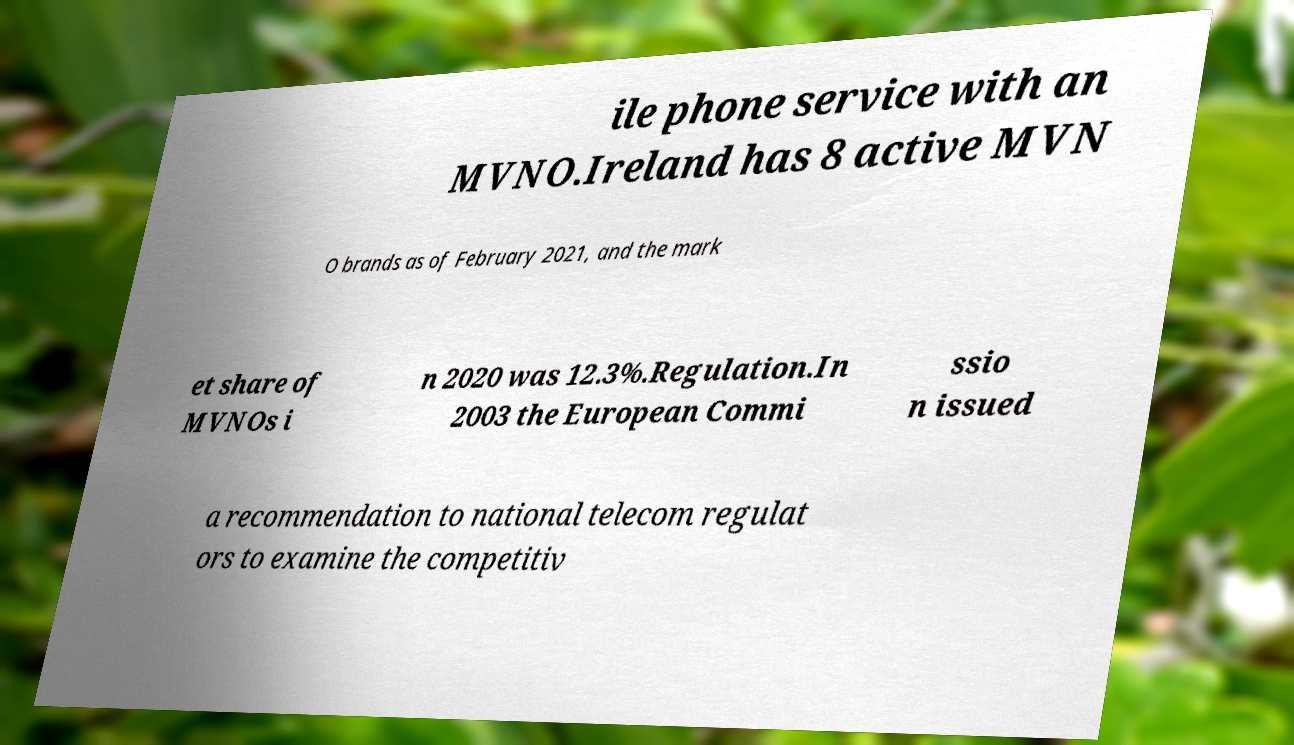Can you accurately transcribe the text from the provided image for me? ile phone service with an MVNO.Ireland has 8 active MVN O brands as of February 2021, and the mark et share of MVNOs i n 2020 was 12.3%.Regulation.In 2003 the European Commi ssio n issued a recommendation to national telecom regulat ors to examine the competitiv 